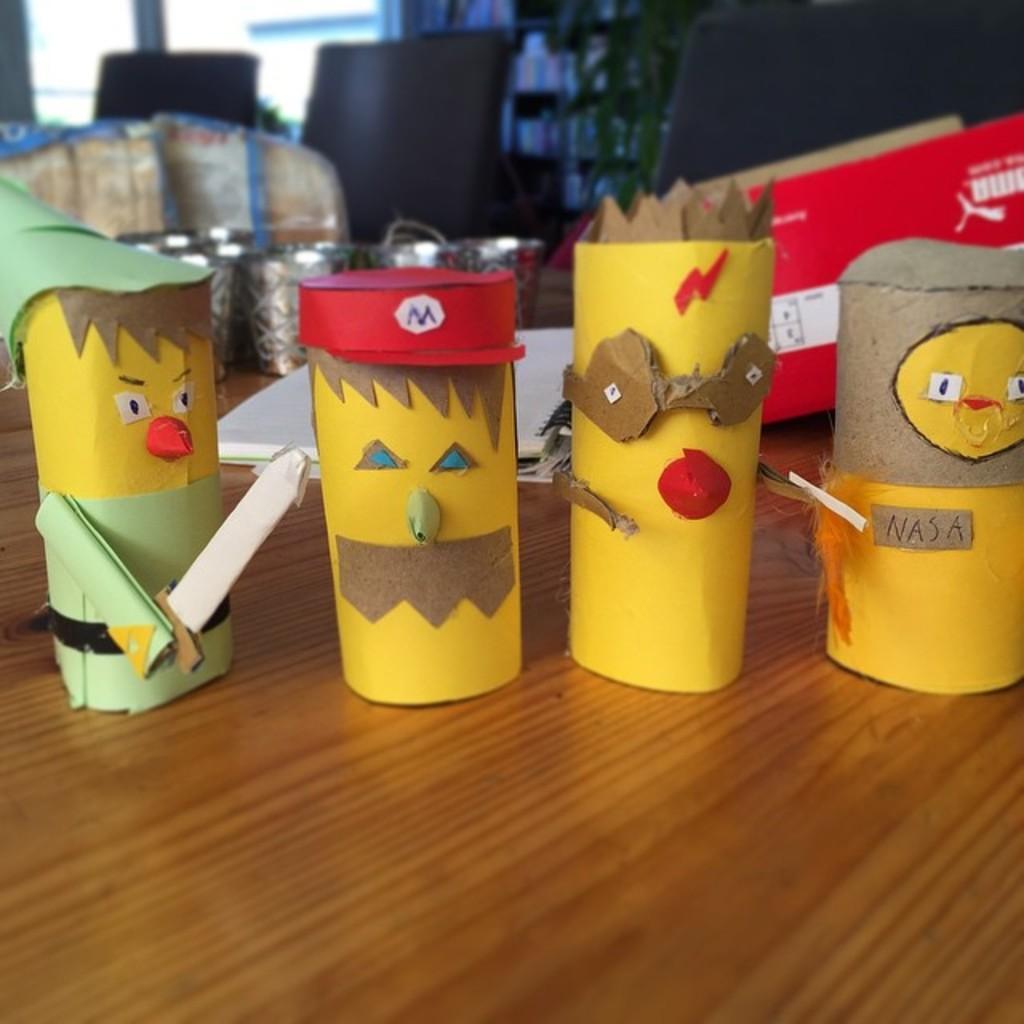Can you describe this image briefly? In the foreground there is a wooden table, on the table there are paper toys, books, box, jars, desktops and various objects. In the background it is window. 